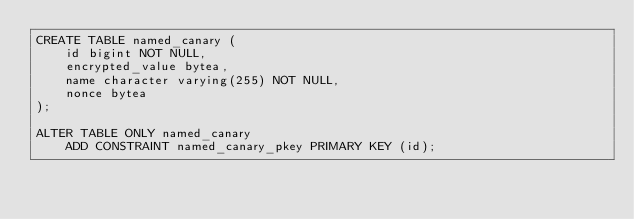Convert code to text. <code><loc_0><loc_0><loc_500><loc_500><_SQL_>CREATE TABLE named_canary (
    id bigint NOT NULL,
    encrypted_value bytea,
    name character varying(255) NOT NULL,
    nonce bytea
);

ALTER TABLE ONLY named_canary
    ADD CONSTRAINT named_canary_pkey PRIMARY KEY (id);
</code> 